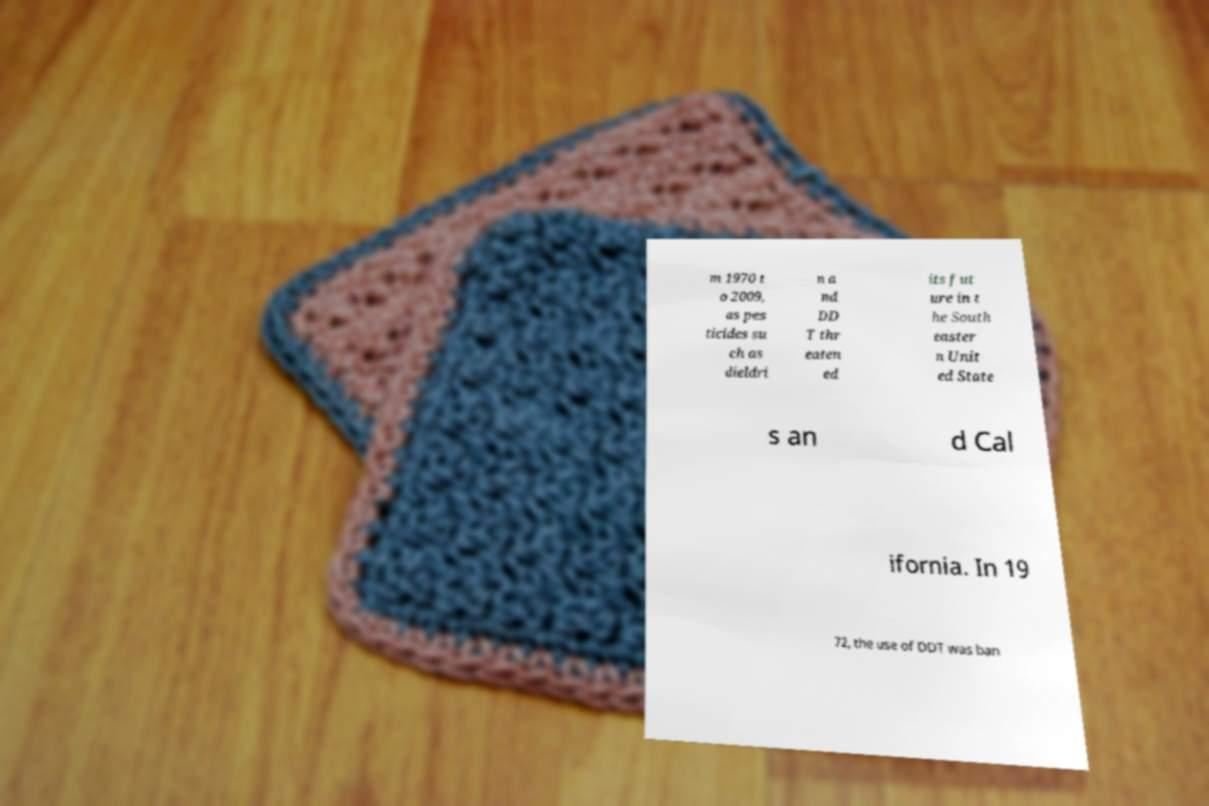For documentation purposes, I need the text within this image transcribed. Could you provide that? m 1970 t o 2009, as pes ticides su ch as dieldri n a nd DD T thr eaten ed its fut ure in t he South easter n Unit ed State s an d Cal ifornia. In 19 72, the use of DDT was ban 